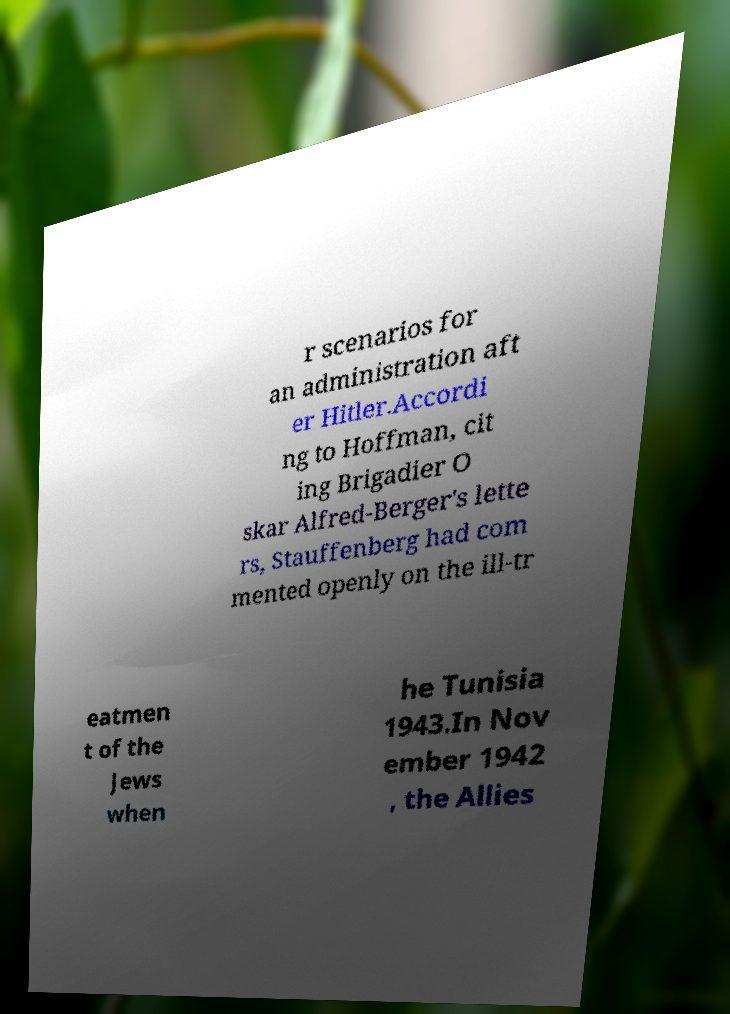Can you read and provide the text displayed in the image?This photo seems to have some interesting text. Can you extract and type it out for me? r scenarios for an administration aft er Hitler.Accordi ng to Hoffman, cit ing Brigadier O skar Alfred-Berger's lette rs, Stauffenberg had com mented openly on the ill-tr eatmen t of the Jews when he Tunisia 1943.In Nov ember 1942 , the Allies 